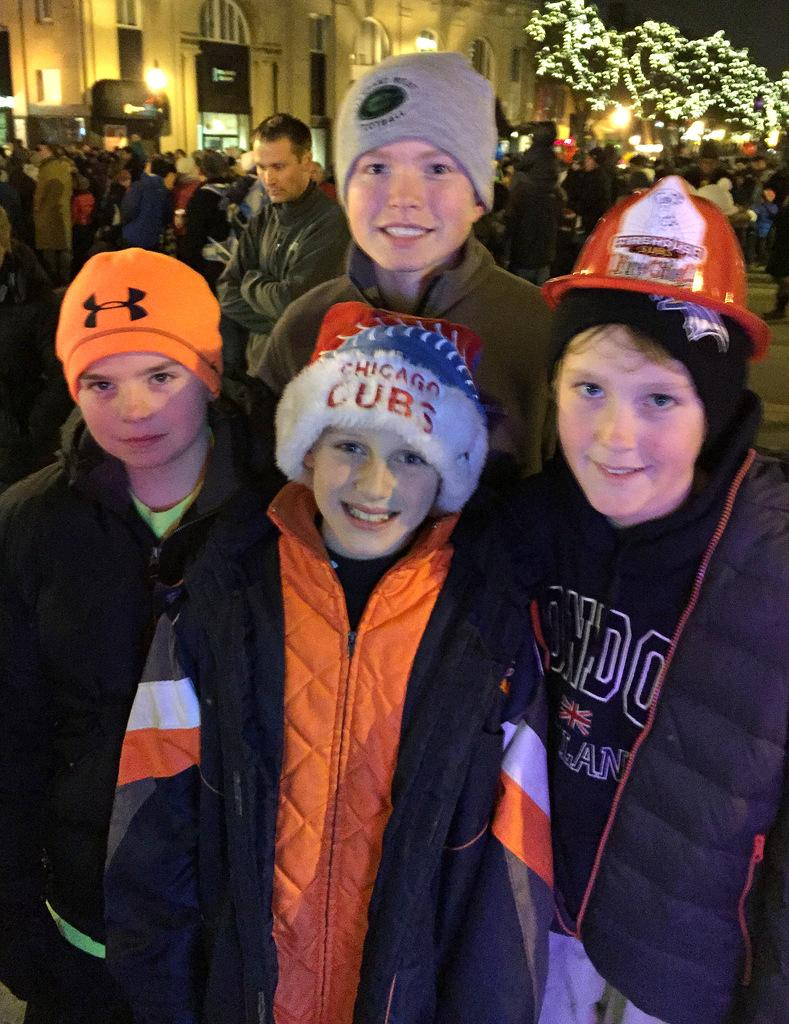How many people are visible in the image? There are many people in the image. Can you describe the attire of the four persons in the front? The four persons in the front are wearing caps and jackets. What can be seen in the background of the image? In the background, there is a building and a tree. What type of peace symbol can be seen in the image? There is no peace symbol present in the image. What is the relation between the four persons in the front? The provided facts do not give any information about the relationship between the four persons in the front. 